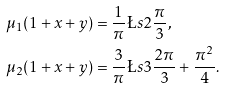Convert formula to latex. <formula><loc_0><loc_0><loc_500><loc_500>\mu _ { 1 } ( 1 + x + y ) & = \frac { 1 } { \pi } \L s { 2 } { \frac { \pi } { 3 } } , \\ \mu _ { 2 } ( 1 + x + y ) & = \frac { 3 } { \pi } \L s { 3 } { \frac { 2 \pi } { 3 } } + \frac { \pi ^ { 2 } } { 4 } .</formula> 